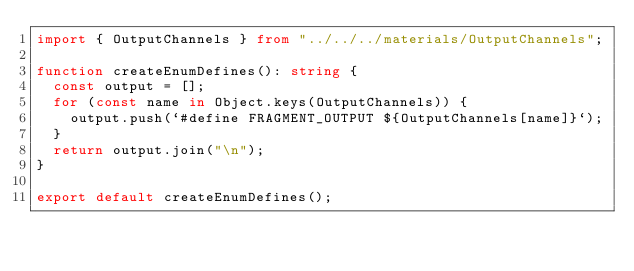<code> <loc_0><loc_0><loc_500><loc_500><_TypeScript_>import { OutputChannels } from "../../../materials/OutputChannels";

function createEnumDefines(): string {
  const output = [];
  for (const name in Object.keys(OutputChannels)) {
    output.push(`#define FRAGMENT_OUTPUT ${OutputChannels[name]}`);
  }
  return output.join("\n");
}

export default createEnumDefines();
</code> 